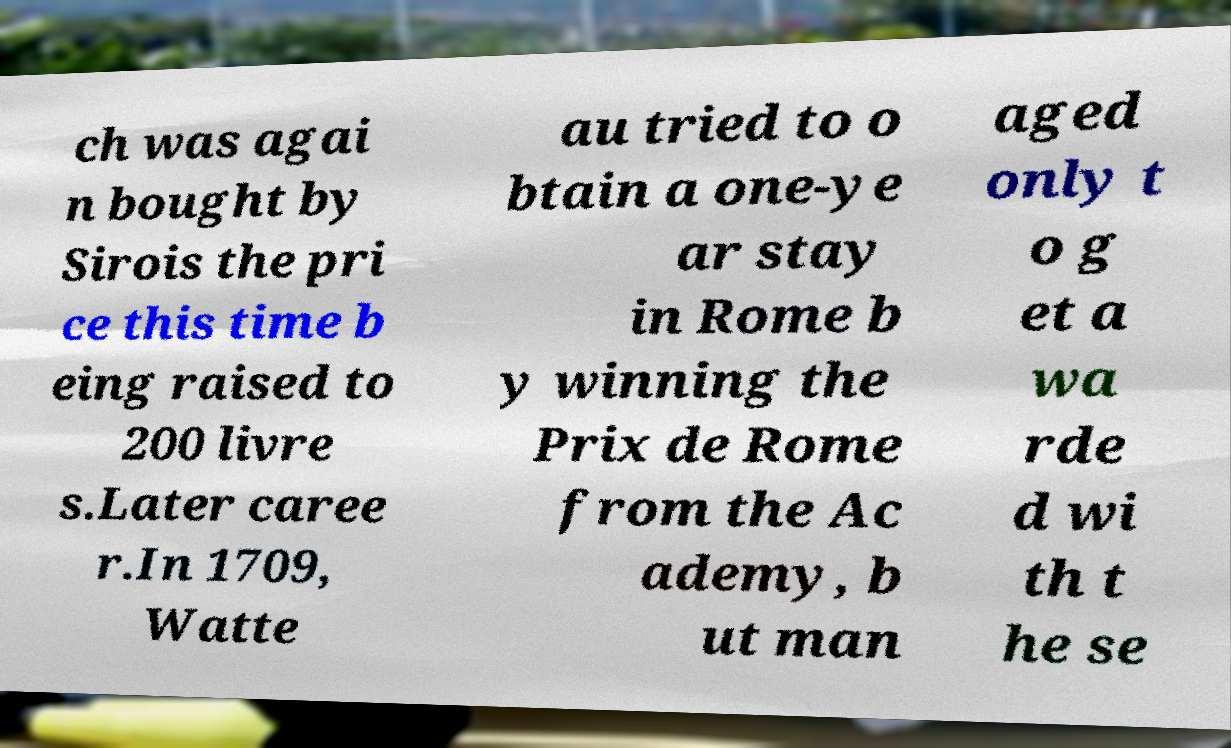Please identify and transcribe the text found in this image. ch was agai n bought by Sirois the pri ce this time b eing raised to 200 livre s.Later caree r.In 1709, Watte au tried to o btain a one-ye ar stay in Rome b y winning the Prix de Rome from the Ac ademy, b ut man aged only t o g et a wa rde d wi th t he se 